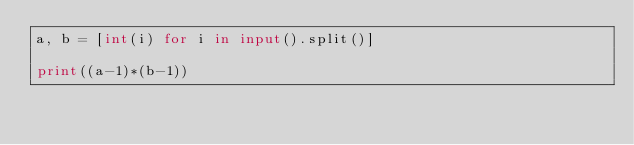Convert code to text. <code><loc_0><loc_0><loc_500><loc_500><_Python_>a, b = [int(i) for i in input().split()]

print((a-1)*(b-1))</code> 